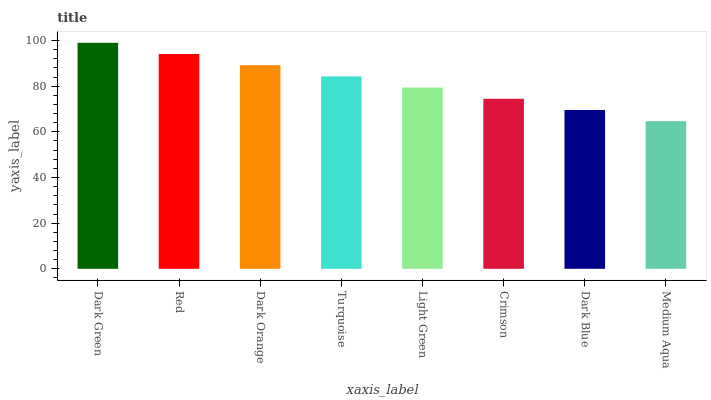Is Medium Aqua the minimum?
Answer yes or no. Yes. Is Dark Green the maximum?
Answer yes or no. Yes. Is Red the minimum?
Answer yes or no. No. Is Red the maximum?
Answer yes or no. No. Is Dark Green greater than Red?
Answer yes or no. Yes. Is Red less than Dark Green?
Answer yes or no. Yes. Is Red greater than Dark Green?
Answer yes or no. No. Is Dark Green less than Red?
Answer yes or no. No. Is Turquoise the high median?
Answer yes or no. Yes. Is Light Green the low median?
Answer yes or no. Yes. Is Light Green the high median?
Answer yes or no. No. Is Turquoise the low median?
Answer yes or no. No. 